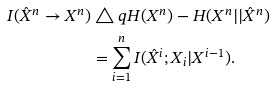Convert formula to latex. <formula><loc_0><loc_0><loc_500><loc_500>I ( \hat { X } ^ { n } \rightarrow X ^ { n } ) & \triangle q H ( X ^ { n } ) - H ( X ^ { n } | | \hat { X } ^ { n } ) \\ & = \sum _ { i = 1 } ^ { n } I ( \hat { X } ^ { i } ; X _ { i } | X ^ { i - 1 } ) .</formula> 